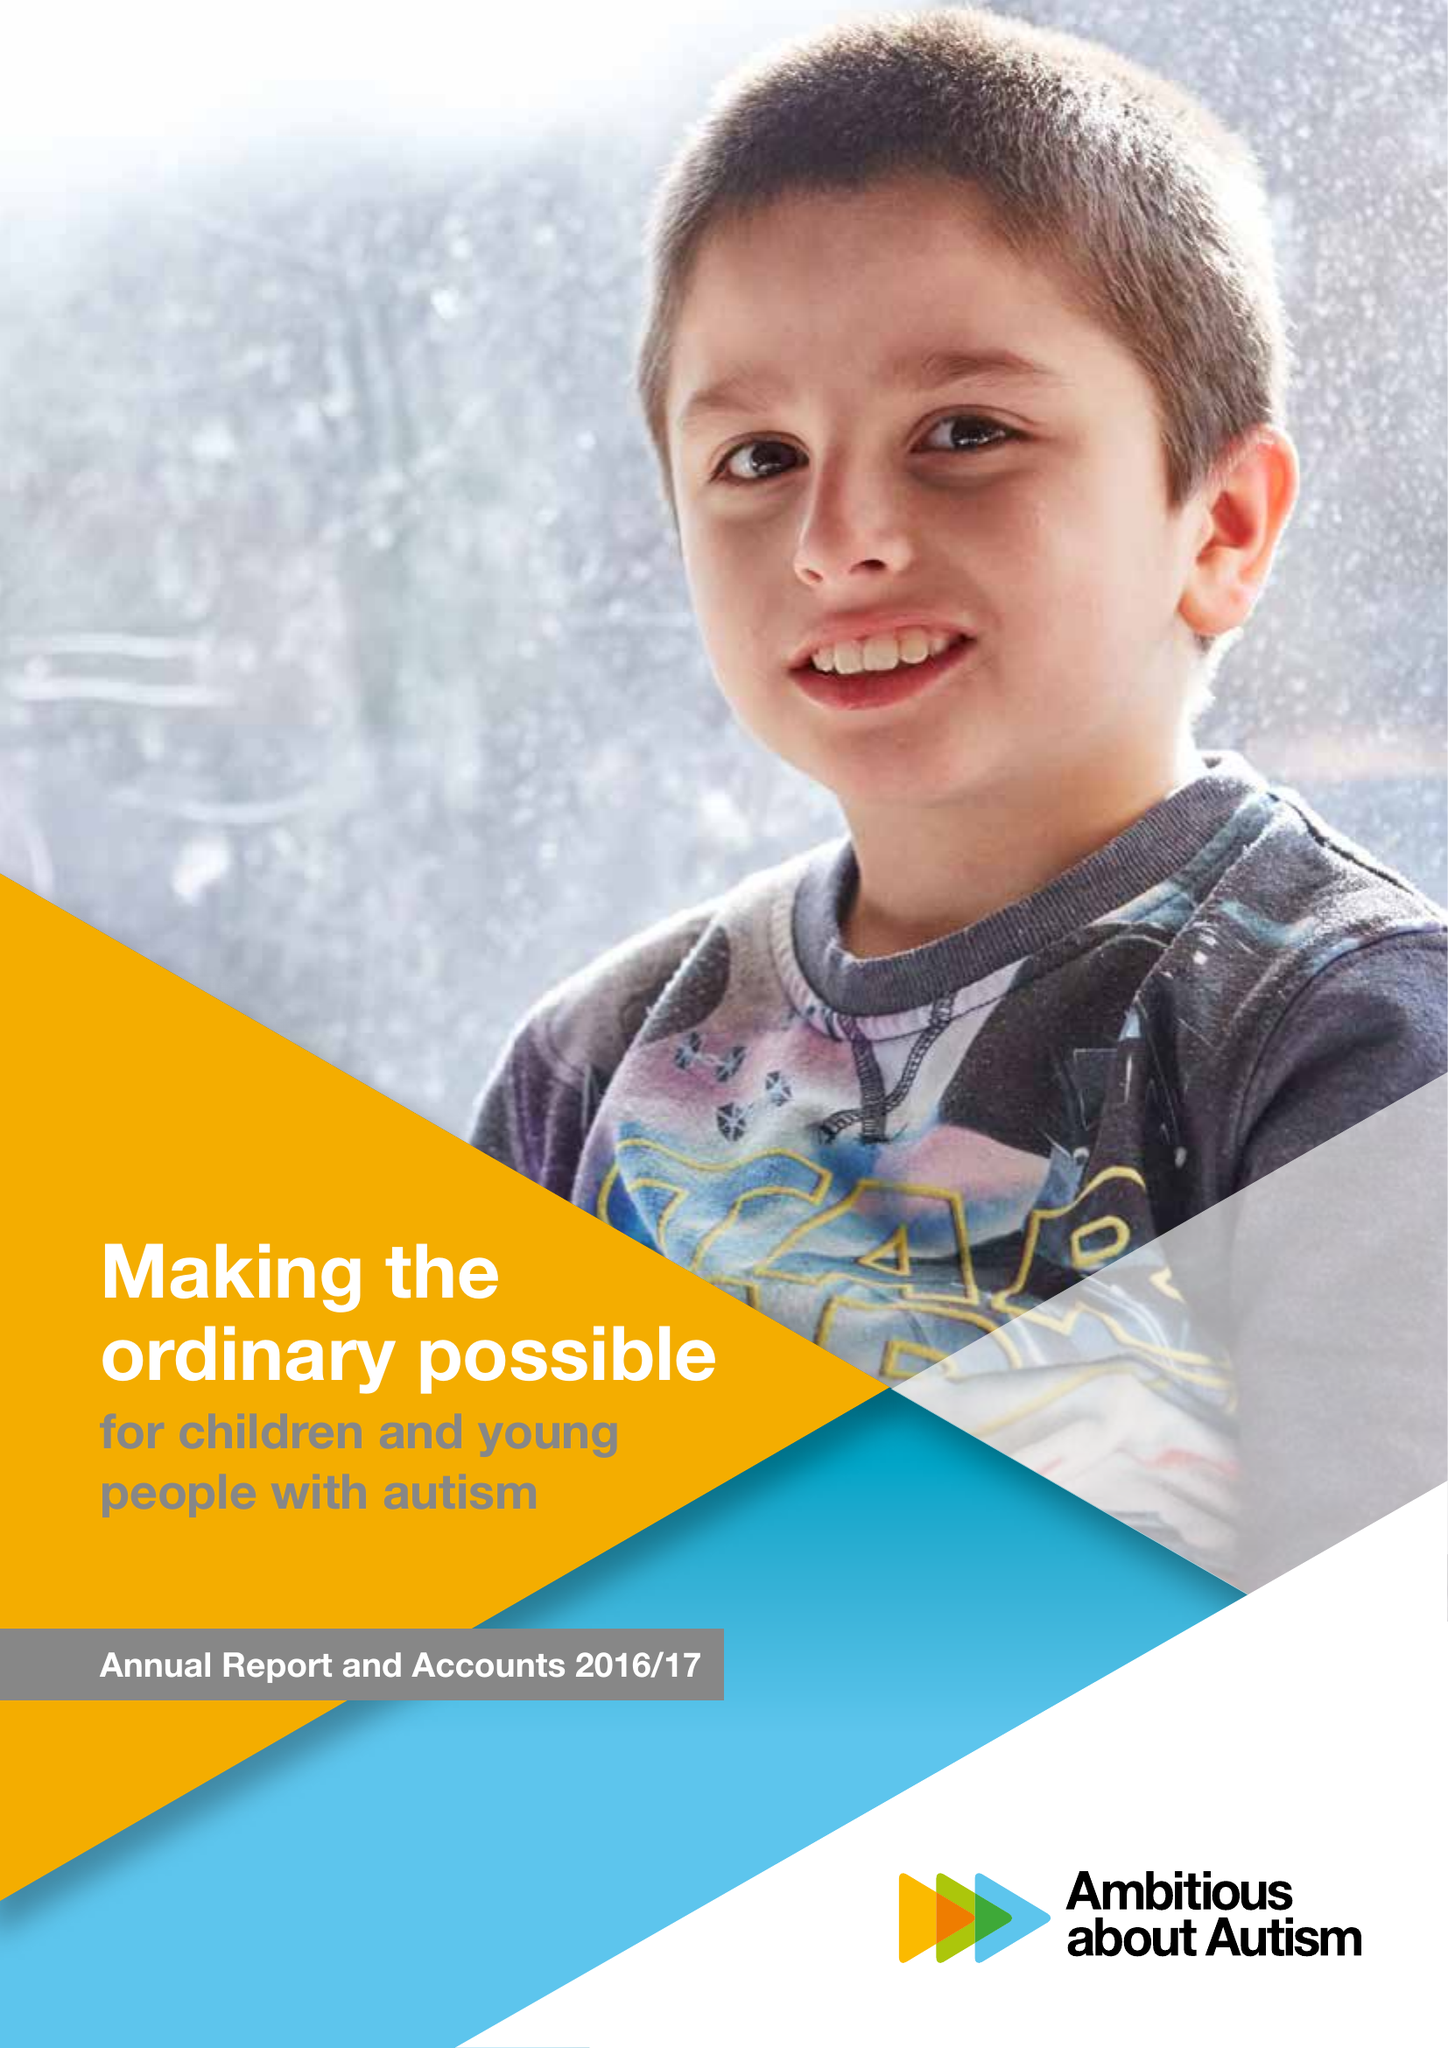What is the value for the income_annually_in_british_pounds?
Answer the question using a single word or phrase. 23209000.00 